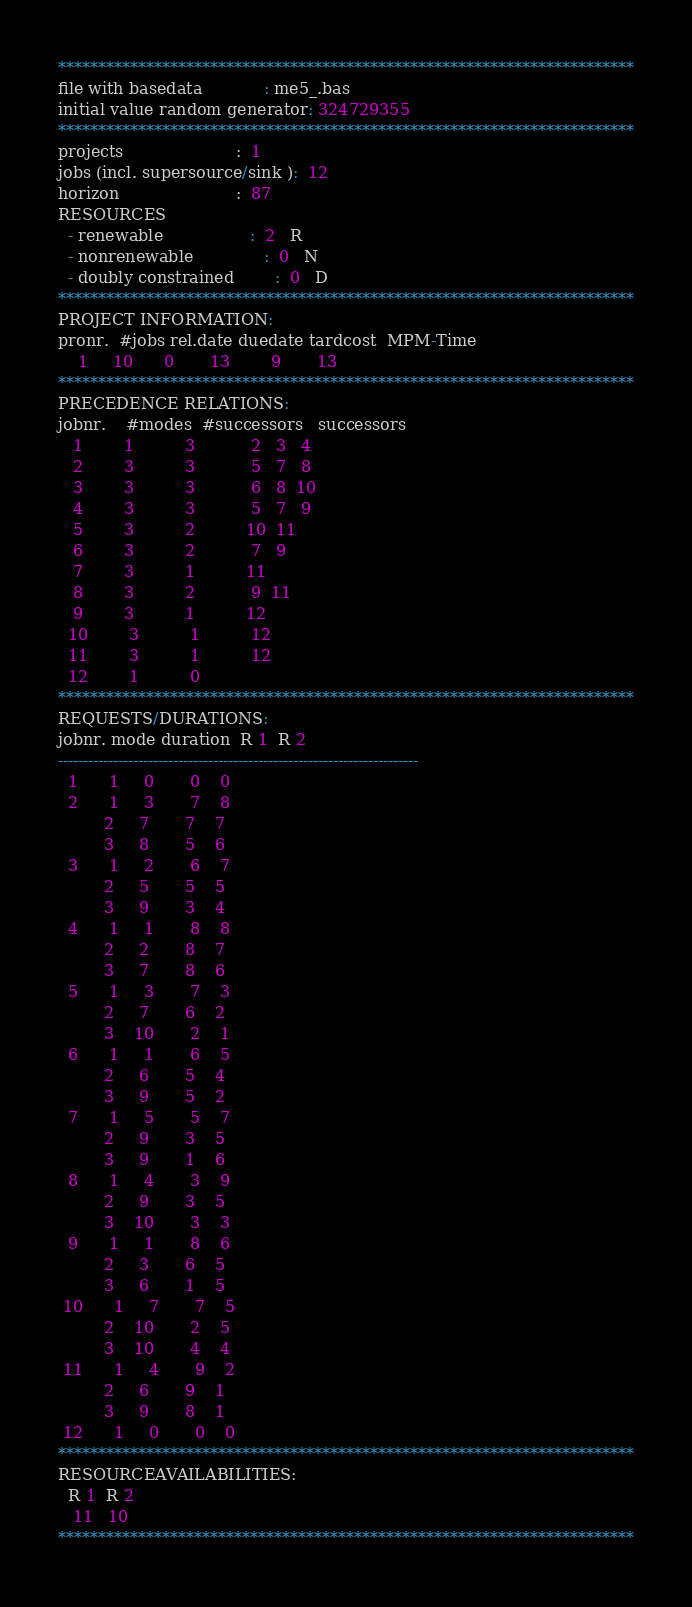Convert code to text. <code><loc_0><loc_0><loc_500><loc_500><_ObjectiveC_>************************************************************************
file with basedata            : me5_.bas
initial value random generator: 324729355
************************************************************************
projects                      :  1
jobs (incl. supersource/sink ):  12
horizon                       :  87
RESOURCES
  - renewable                 :  2   R
  - nonrenewable              :  0   N
  - doubly constrained        :  0   D
************************************************************************
PROJECT INFORMATION:
pronr.  #jobs rel.date duedate tardcost  MPM-Time
    1     10      0       13        9       13
************************************************************************
PRECEDENCE RELATIONS:
jobnr.    #modes  #successors   successors
   1        1          3           2   3   4
   2        3          3           5   7   8
   3        3          3           6   8  10
   4        3          3           5   7   9
   5        3          2          10  11
   6        3          2           7   9
   7        3          1          11
   8        3          2           9  11
   9        3          1          12
  10        3          1          12
  11        3          1          12
  12        1          0        
************************************************************************
REQUESTS/DURATIONS:
jobnr. mode duration  R 1  R 2
------------------------------------------------------------------------
  1      1     0       0    0
  2      1     3       7    8
         2     7       7    7
         3     8       5    6
  3      1     2       6    7
         2     5       5    5
         3     9       3    4
  4      1     1       8    8
         2     2       8    7
         3     7       8    6
  5      1     3       7    3
         2     7       6    2
         3    10       2    1
  6      1     1       6    5
         2     6       5    4
         3     9       5    2
  7      1     5       5    7
         2     9       3    5
         3     9       1    6
  8      1     4       3    9
         2     9       3    5
         3    10       3    3
  9      1     1       8    6
         2     3       6    5
         3     6       1    5
 10      1     7       7    5
         2    10       2    5
         3    10       4    4
 11      1     4       9    2
         2     6       9    1
         3     9       8    1
 12      1     0       0    0
************************************************************************
RESOURCEAVAILABILITIES:
  R 1  R 2
   11   10
************************************************************************
</code> 